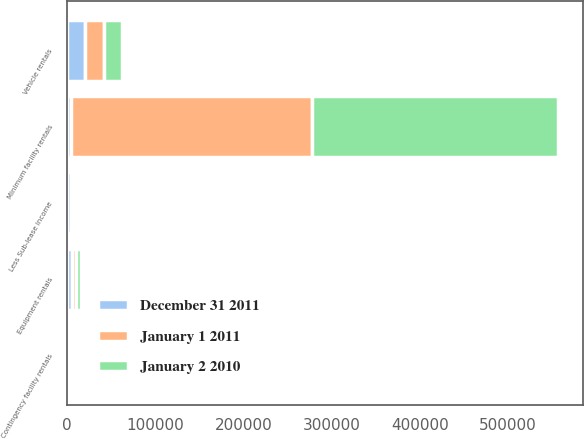Convert chart to OTSL. <chart><loc_0><loc_0><loc_500><loc_500><stacked_bar_chart><ecel><fcel>Minimum facility rentals<fcel>Contingency facility rentals<fcel>Equipment rentals<fcel>Vehicle rentals<fcel>Less Sub-lease income<nl><fcel>December 31 2011<fcel>5055<fcel>1162<fcel>5403<fcel>20565<fcel>3967<nl><fcel>January 2 2010<fcel>279099<fcel>1115<fcel>5372<fcel>19903<fcel>3813<nl><fcel>January 1 2011<fcel>272686<fcel>729<fcel>4738<fcel>21403<fcel>3652<nl></chart> 